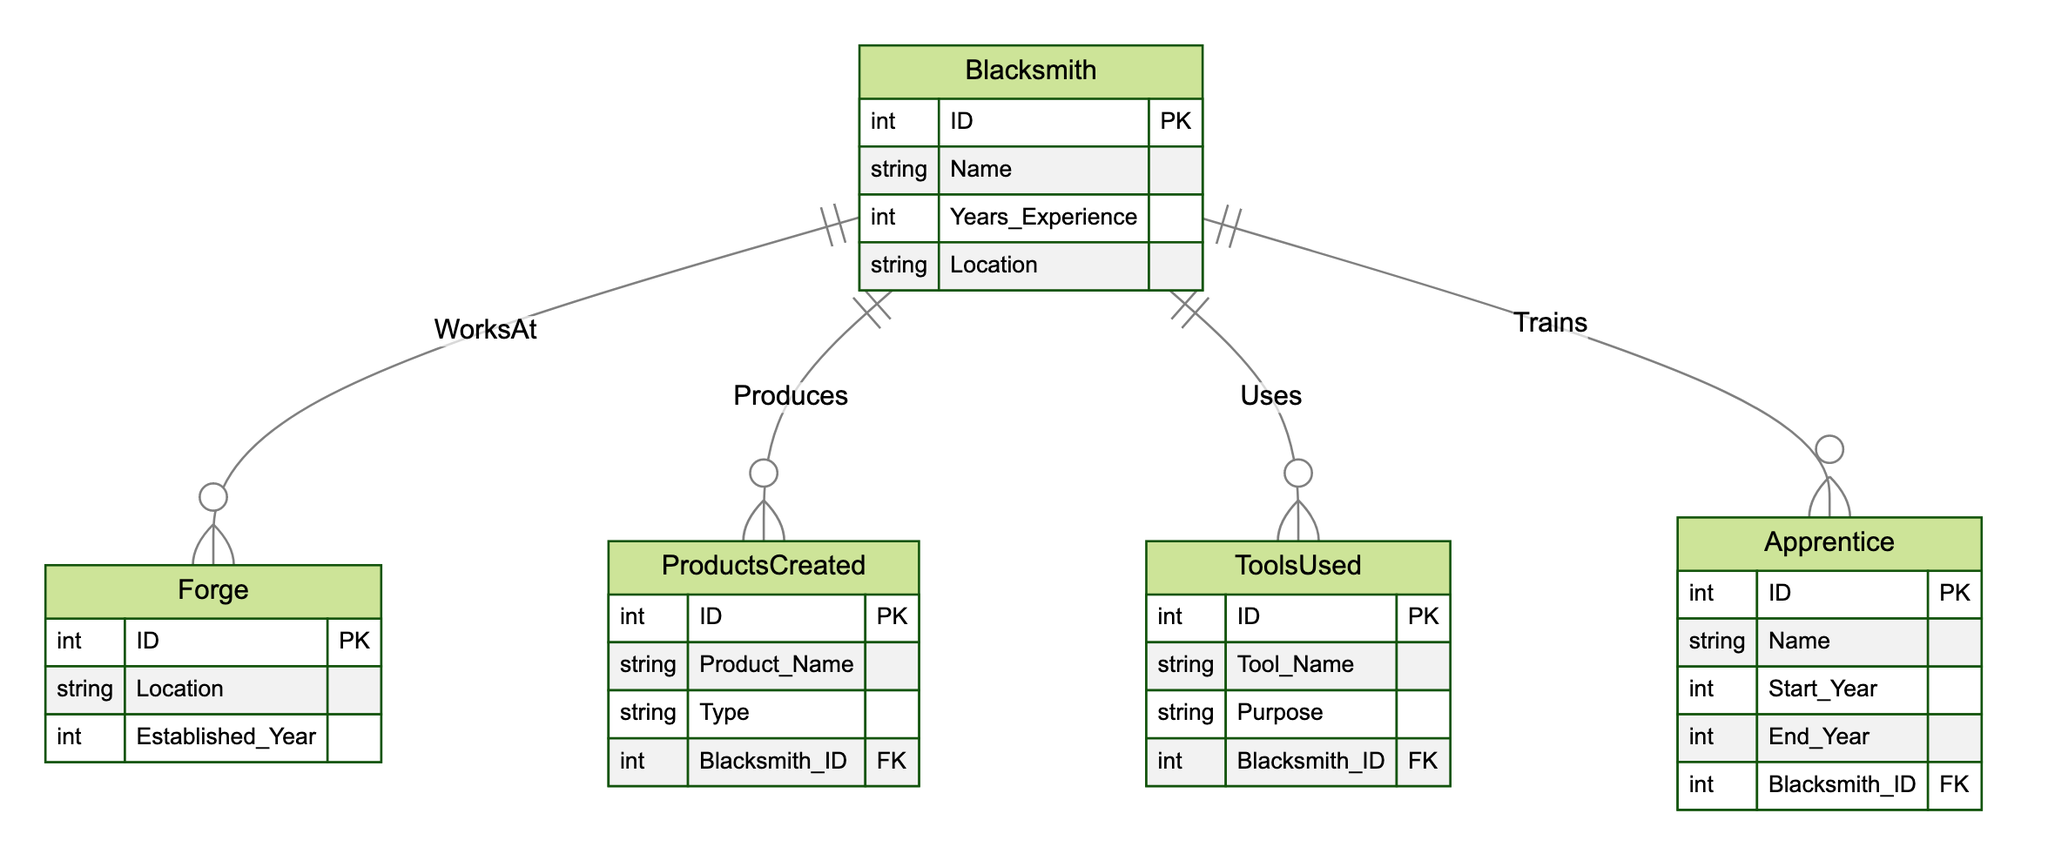What are the main entities represented in the diagram? The main entities represented in the diagram are Blacksmith, Forge, Products Created, Tools Used, and Apprentice. Each of these entities is crucial in understanding the relationships and functions within the blacksmithing tradition.
Answer: Blacksmith, Forge, Products Created, Tools Used, Apprentice How many relationships does the Blacksmith have in the diagram? The Blacksmith has four relationships in the diagram, connecting to the Forge, Products Created, Tools Used, and Apprentice entities. Each relationship denotes a different aspect of the Blacksmith's activities.
Answer: Four What is the purpose of the "WorksAt" relationship? The "WorksAt" relationship indicates the connection between a Blacksmith and a Forge, specifying where the Blacksmith practices their craft. This relationship is foundational to understanding the blacksmithing environment.
Answer: Location of Forge What types of products can a Blacksmith create? A Blacksmith can create various products that are defined within the ProductsCreated entity, which includes the product name and type associated with the Blacksmith ID. The exact types depend on the individual Blacksmith's specialization.
Answer: Products Created What does a Blacksmith use according to the diagram? According to the diagram, a Blacksmith uses various ToolsUsed, which are associated with specific purposes related to their work. Each tool is linked to a particular Blacksmith, indicating the tools are utilized by them.
Answer: Tools Used How does the "Trains" relationship function? The "Trains" relationship illustrates the connection between a Blacksmith and an Apprentice, indicating that the Blacksmith is responsible for mentoring and educating the Apprentice in the craft of blacksmithing. This showcases the importance of apprenticeship.
Answer: Mentoring Apprentices In which year must a Forge have been established to be included in this diagram? The Established Year attribute in the Forge entity determines the timeframe of when a Forge was founded. Inclusion requires the forge to have a valid Established Year related to the 19th century American West.
Answer: Established Year What type of attributes does the ToolsUsed entity contain? The ToolsUsed entity includes attributes such as Tool_Name, Purpose, and Blacksmith_ID, which collaboratively provide information about the tools used by Blacksmiths and their intended functions in the crafting process.
Answer: Tool_Name, Purpose, Blacksmith_ID Which entity relates directly to the historical timeline of blacksmithing apprenticeships? The Apprentice entity directly relates to the historical timeline of blacksmithing apprenticeships, capturing information about the Apprentice's duration of training with a Blacksmith, including their Start and End Year.
Answer: Apprentice 